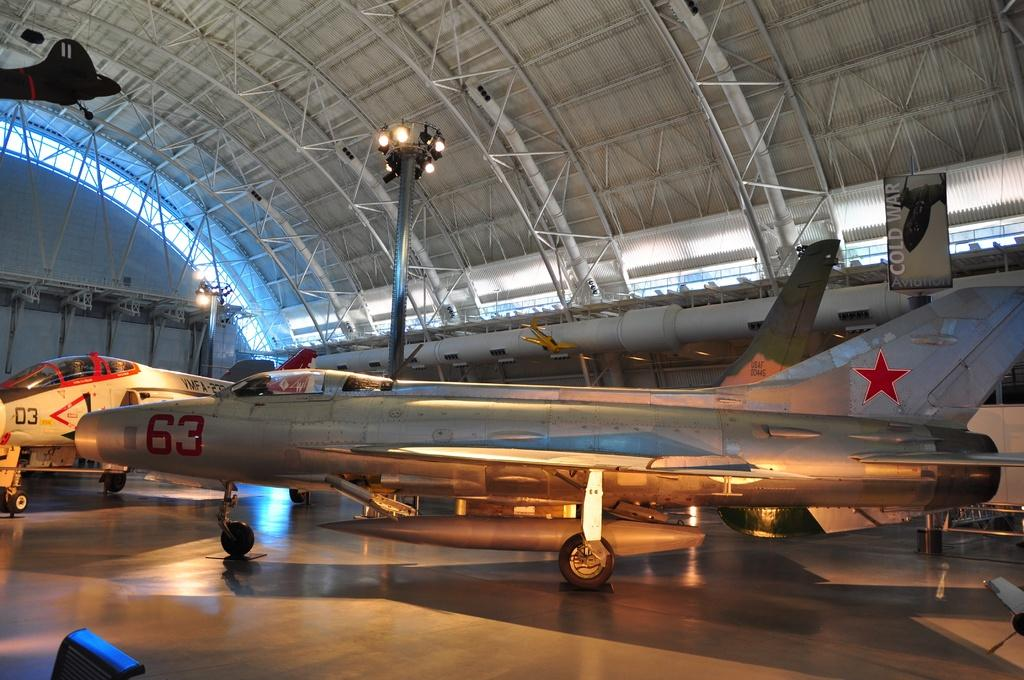<image>
Write a terse but informative summary of the picture. Plane 63 inside a hanger with plane D3 behind it. 